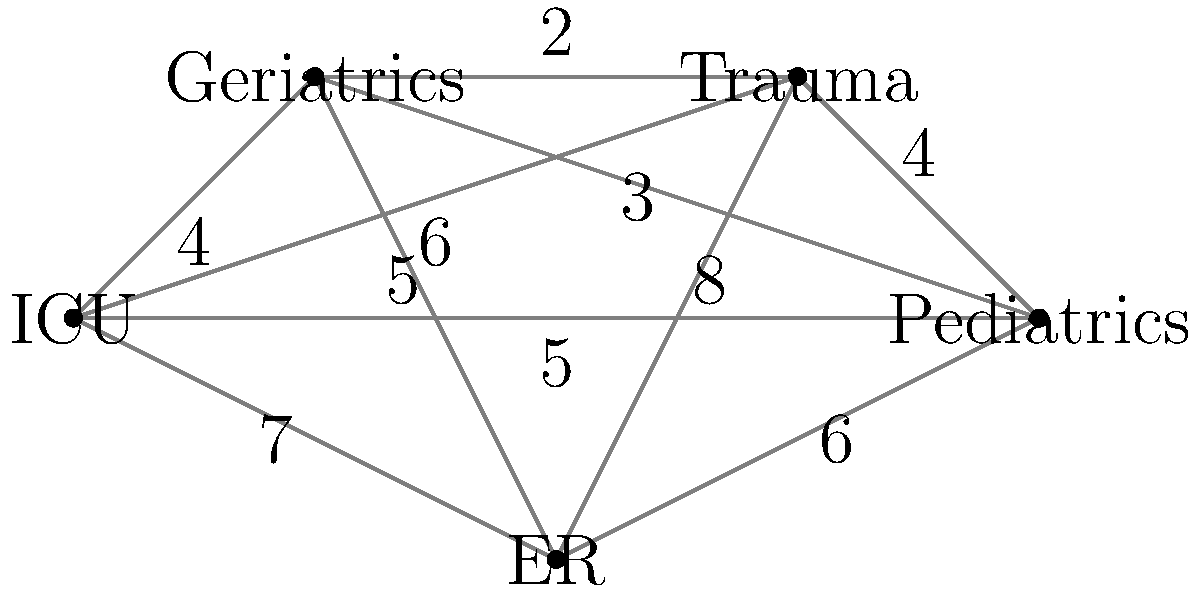Given the graph representing the hospital departments and their interconnectedness, with edge weights indicating the importance of resource sharing between departments, what is the minimum number of connections needed to ensure all departments are linked while maximizing resource allocation efficiency? To solve this problem, we need to find the Minimum Spanning Tree (MST) of the given graph. The MST will connect all departments with the minimum total weight, ensuring optimal resource allocation.

Steps to find the MST using Kruskal's algorithm:

1. Sort all edges by weight in ascending order:
   (Trauma, Geriatrics): 2
   (Pediatrics, Geriatrics): 3
   (Pediatrics, Trauma): 4
   (Geriatrics, ICU): 4
   (ER, Geriatrics): 5
   (Pediatrics, ICU): 5
   (ER, Pediatrics): 6
   (Trauma, ICU): 6
   (ER, ICU): 7
   (ER, Trauma): 8

2. Start with an empty set of edges and add edges in order, skipping those that would create a cycle:
   - Add (Trauma, Geriatrics): 2
   - Add (Pediatrics, Geriatrics): 3
   - Add (Geriatrics, ICU): 4
   - Add (ER, Geriatrics): 5

3. At this point, we have connected all 5 departments with 4 edges, forming the MST.

The MST includes the following connections:
1. Trauma - Geriatrics
2. Pediatrics - Geriatrics
3. Geriatrics - ICU
4. ER - Geriatrics

The total weight of the MST is 2 + 3 + 4 + 5 = 14, representing the optimal resource allocation efficiency.
Answer: 4 connections 